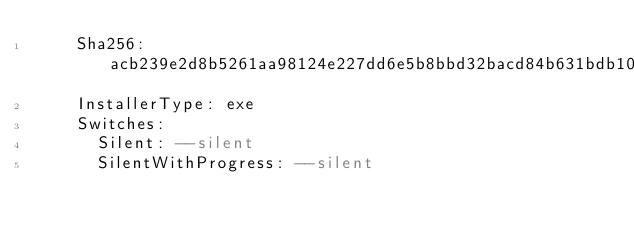Convert code to text. <code><loc_0><loc_0><loc_500><loc_500><_YAML_>    Sha256: acb239e2d8b5261aa98124e227dd6e5b8bbd32bacd84b631bdb1041b53b90bda
    InstallerType: exe
    Switches:
      Silent: --silent
      SilentWithProgress: --silent
</code> 